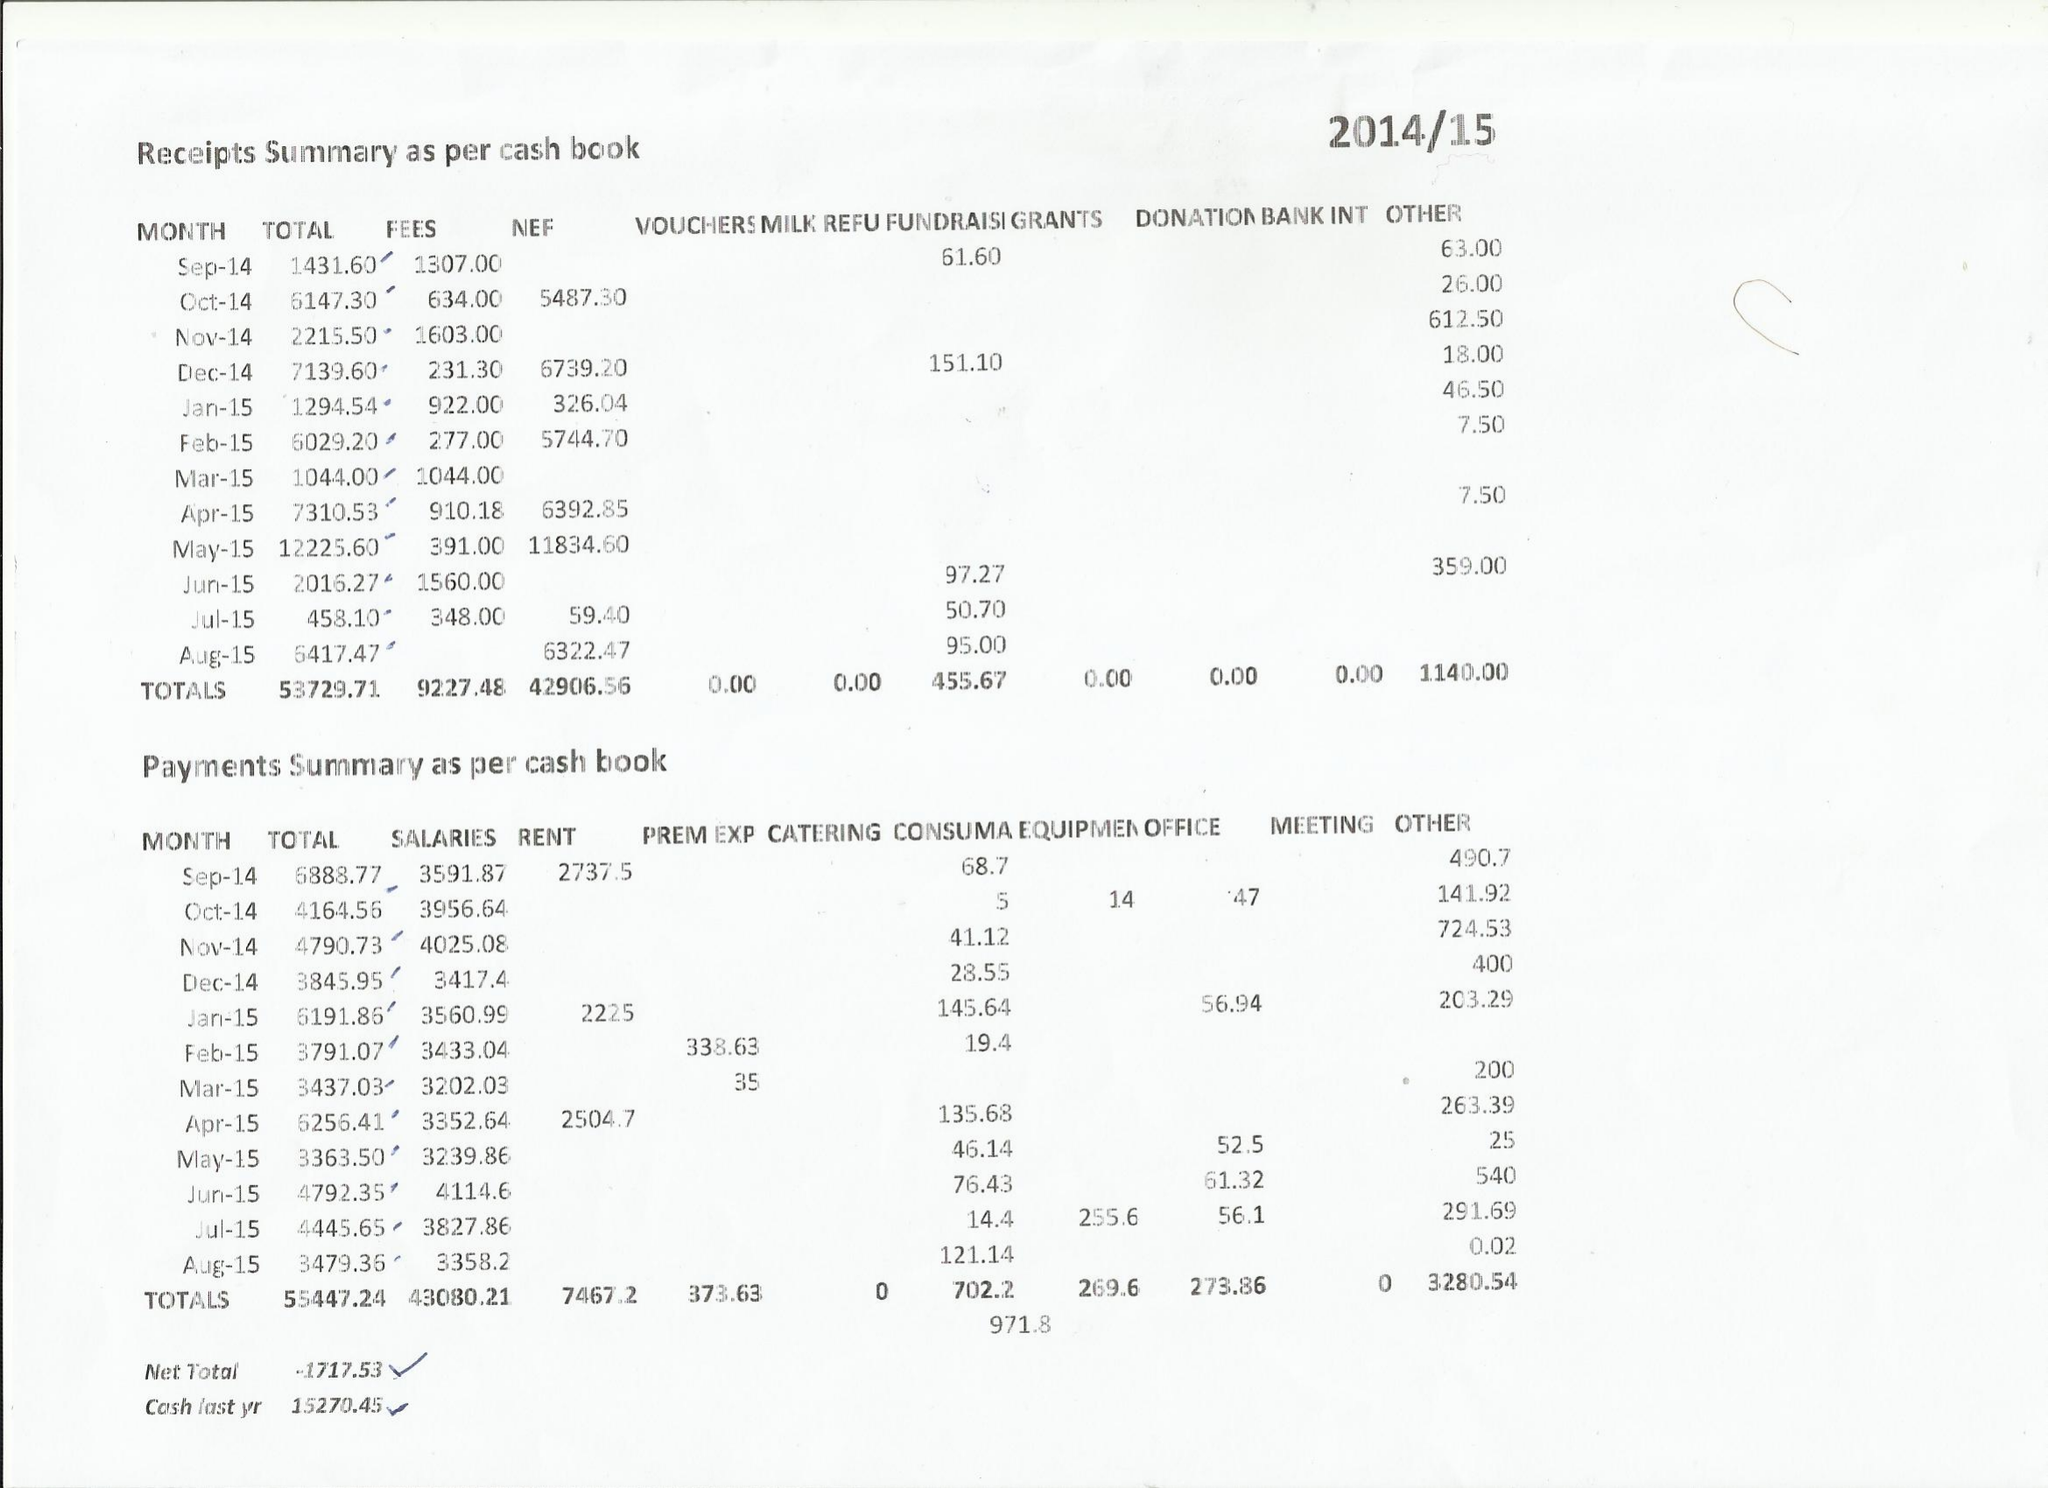What is the value for the address__postcode?
Answer the question using a single word or phrase. ME15 8XG 